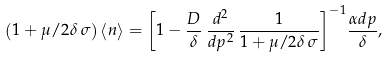<formula> <loc_0><loc_0><loc_500><loc_500>\left ( 1 + \mu / 2 \delta \, \sigma \right ) \left < n \right > = { \left [ 1 - \frac { D } { \delta } \, \frac { d ^ { 2 } } { d p ^ { 2 } } \, \frac { 1 } { 1 + \mu / 2 \delta \, \sigma } \right ] } ^ { - 1 } \frac { \alpha d p } { \delta } ,</formula> 